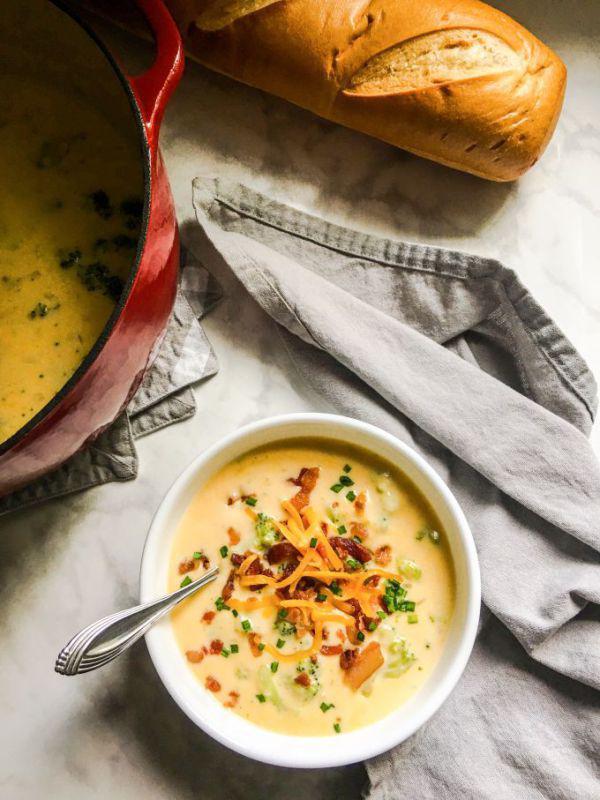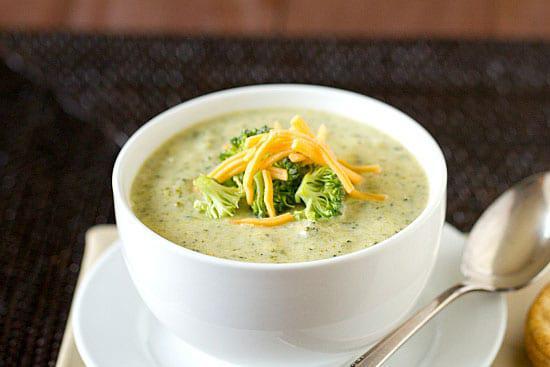The first image is the image on the left, the second image is the image on the right. For the images displayed, is the sentence "A bowl of creamy soup in a white bowl with spoon is garnished with pieces of broccoli and grated cheese." factually correct? Answer yes or no. Yes. 